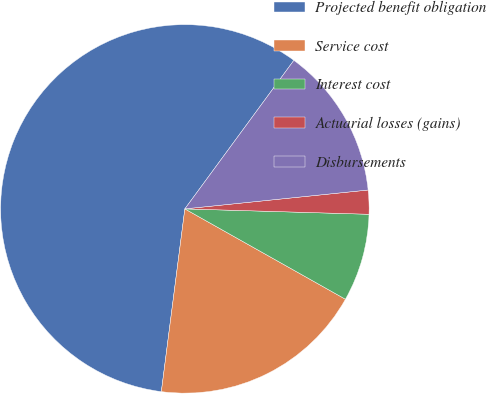Convert chart. <chart><loc_0><loc_0><loc_500><loc_500><pie_chart><fcel>Projected benefit obligation<fcel>Service cost<fcel>Interest cost<fcel>Actuarial losses (gains)<fcel>Disbursements<nl><fcel>58.04%<fcel>18.88%<fcel>7.69%<fcel>2.1%<fcel>13.29%<nl></chart> 